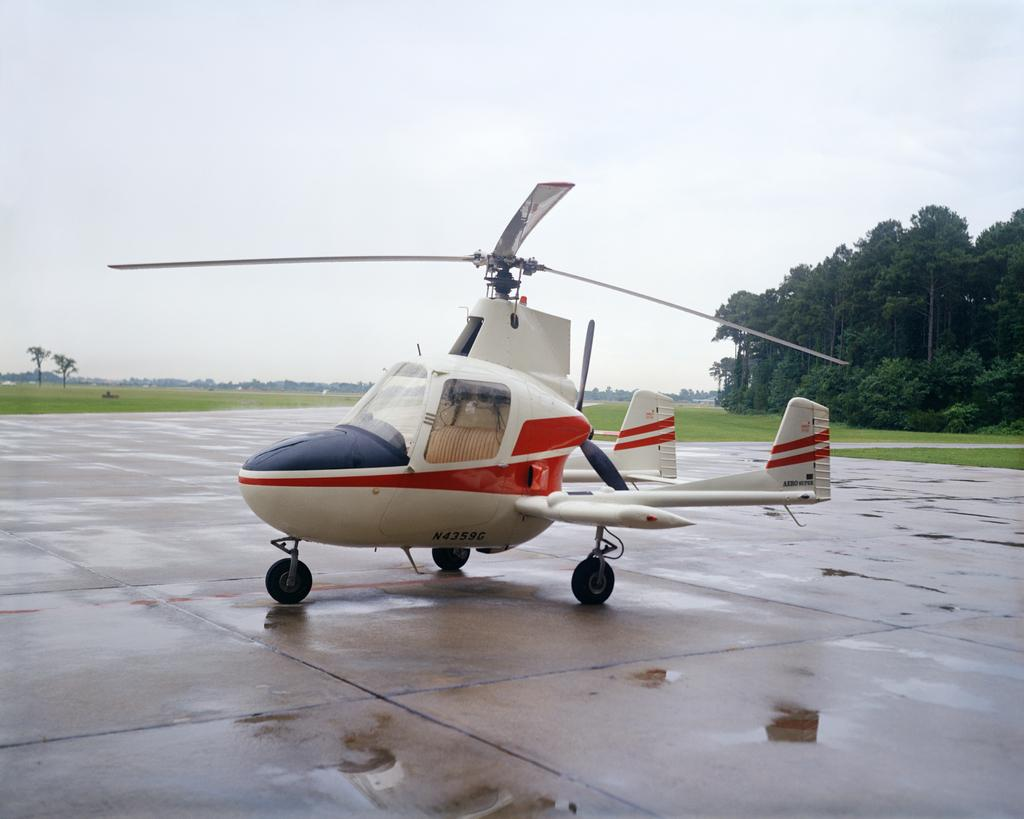What type of vehicle is on the ground in the image? There is a helicopter on the ground in the image. What can be seen on the right side of the image? There are trees on the right side of the image. What type of vegetation is visible in the background of the image? Grass is visible in the background of the image. What is visible in the sky in the image? The sky is visible in the background of the image. What type of liquid can be seen flowing from the helicopter in the image? There is no liquid flowing from the helicopter in the image; it is stationary on the ground. 